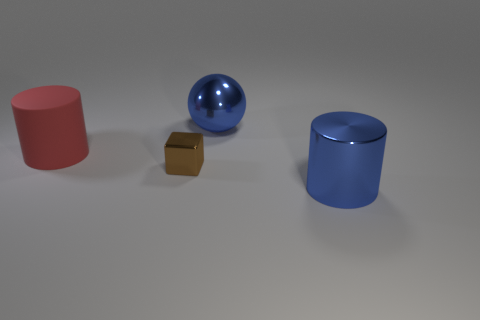What can you tell me about the composition and balance of this image? The composition uses simple geometric forms placed with intention. The spherical and cylindrical shapes provide a sense of visual harmony, while the small brown cube adds interest by breaking the flow with its contrasting shape and color. The arrangement is pleasing to the eye, invoking a minimalist and modern aesthetic.  If this image were part of an advertisement, what product do you think it could be showcasing and why? If this image were used in advertising, it might showcase a home decor brand featuring modern, minimalist design elements. The clean lines, simple shapes, and muted palette are all characteristics that could align with a brand trying to emphasize sophistication and contemporary style. 